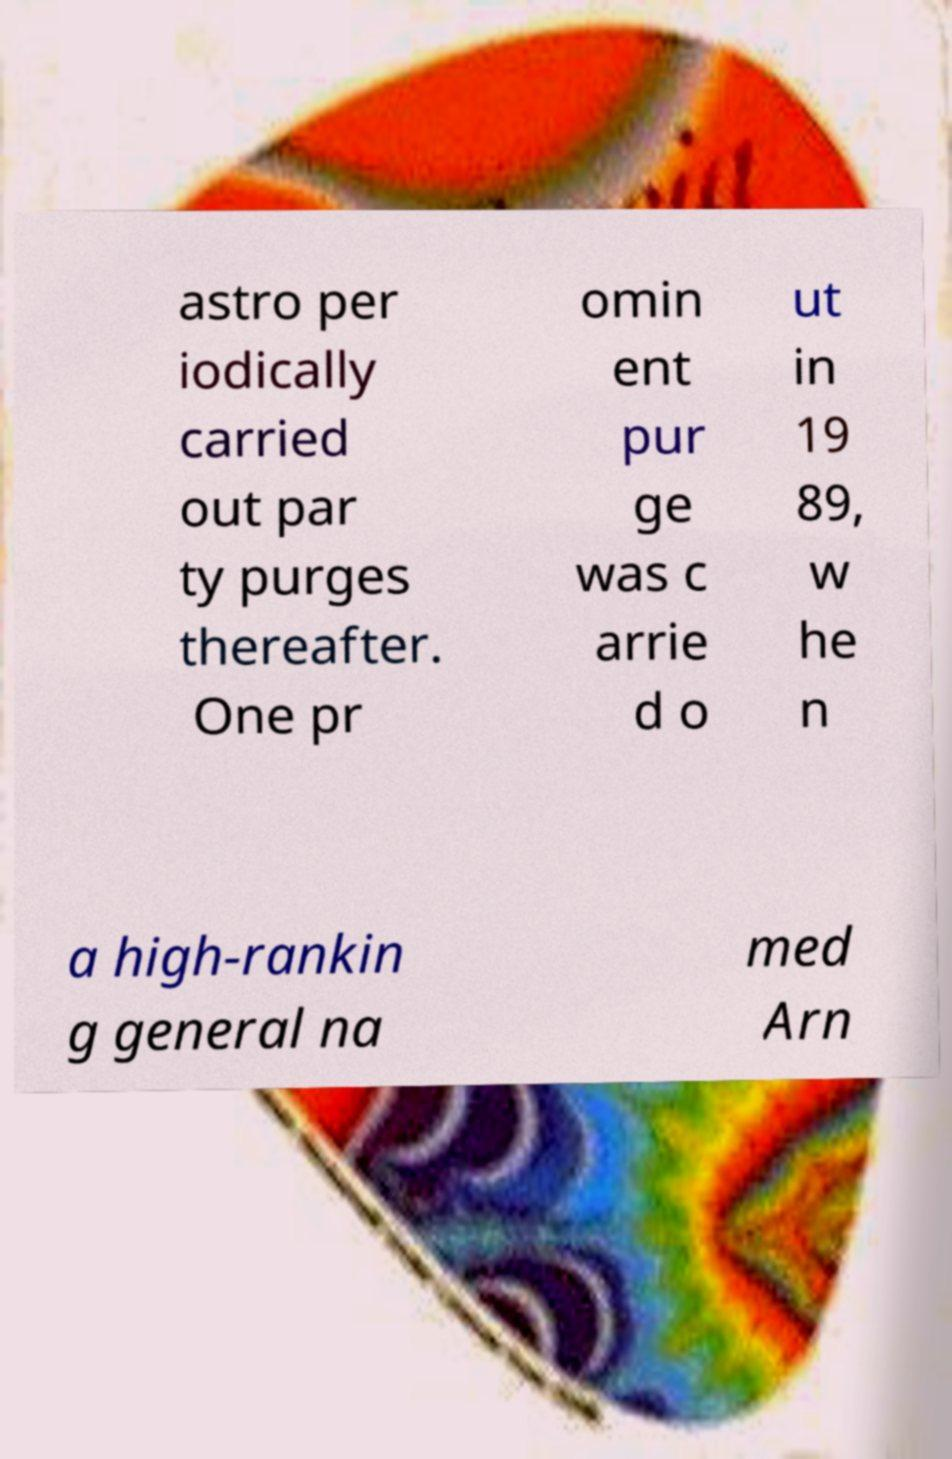I need the written content from this picture converted into text. Can you do that? astro per iodically carried out par ty purges thereafter. One pr omin ent pur ge was c arrie d o ut in 19 89, w he n a high-rankin g general na med Arn 